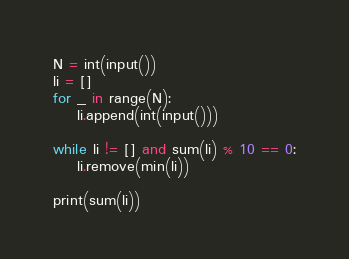<code> <loc_0><loc_0><loc_500><loc_500><_Python_>N = int(input())
li = []
for _ in range(N):
    li.append(int(input()))

while li != [] and sum(li) % 10 == 0:
    li.remove(min(li))

print(sum(li))
</code> 